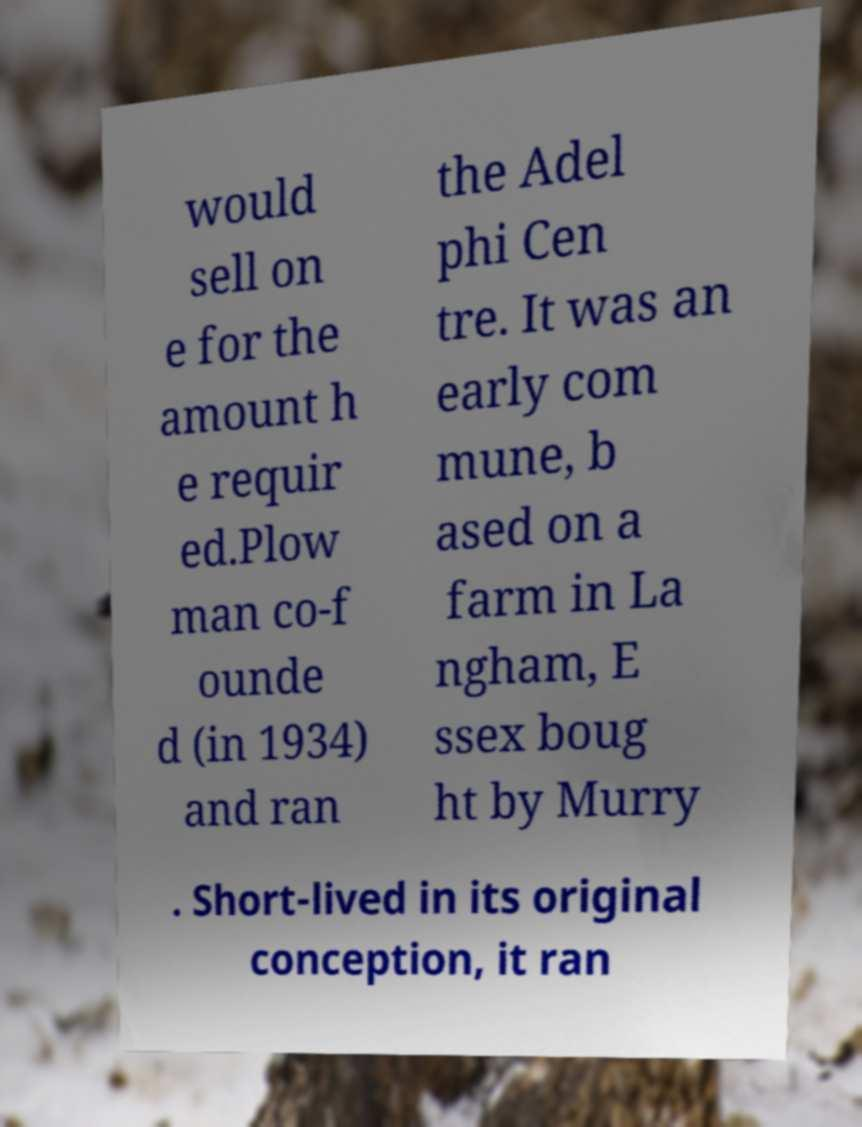For documentation purposes, I need the text within this image transcribed. Could you provide that? would sell on e for the amount h e requir ed.Plow man co-f ounde d (in 1934) and ran the Adel phi Cen tre. It was an early com mune, b ased on a farm in La ngham, E ssex boug ht by Murry . Short-lived in its original conception, it ran 